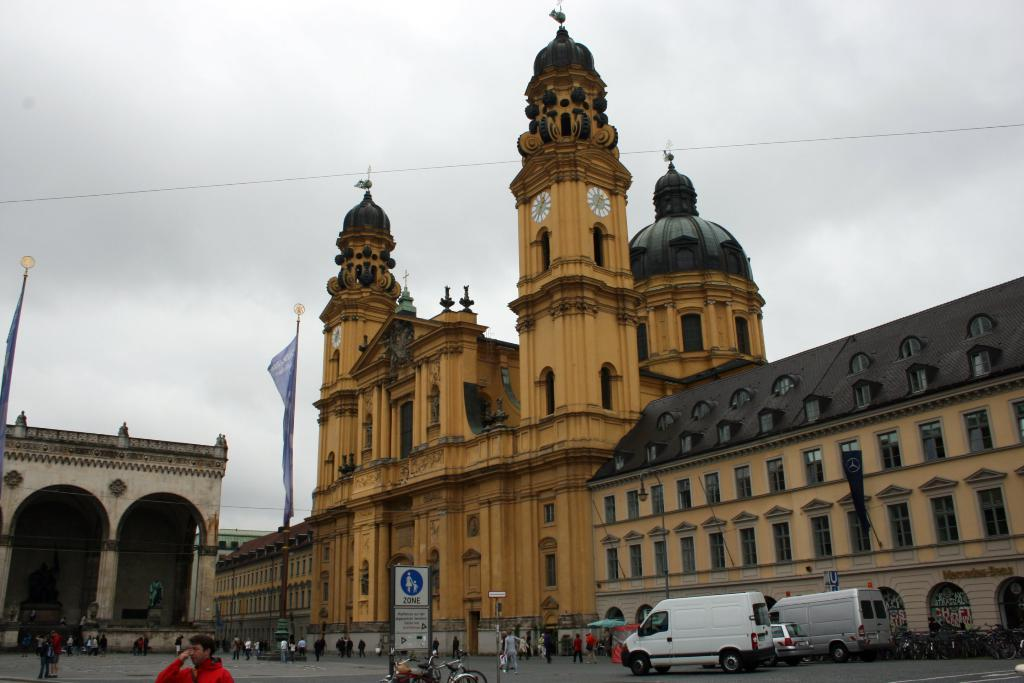What type of structures are visible in the image? There are architectures in the image. Are there any people present in the image? Yes, there are people in front of the architectures. What else can be seen in front of the architectures? There are vehicles in front of the architectures. Is there any additional information provided in the image? Yes, there is a board with some information in the image. Can you see any faces or noses on the architectures in the image? No, there are no faces or noses on the architectures in the image, as they are inanimate structures. 